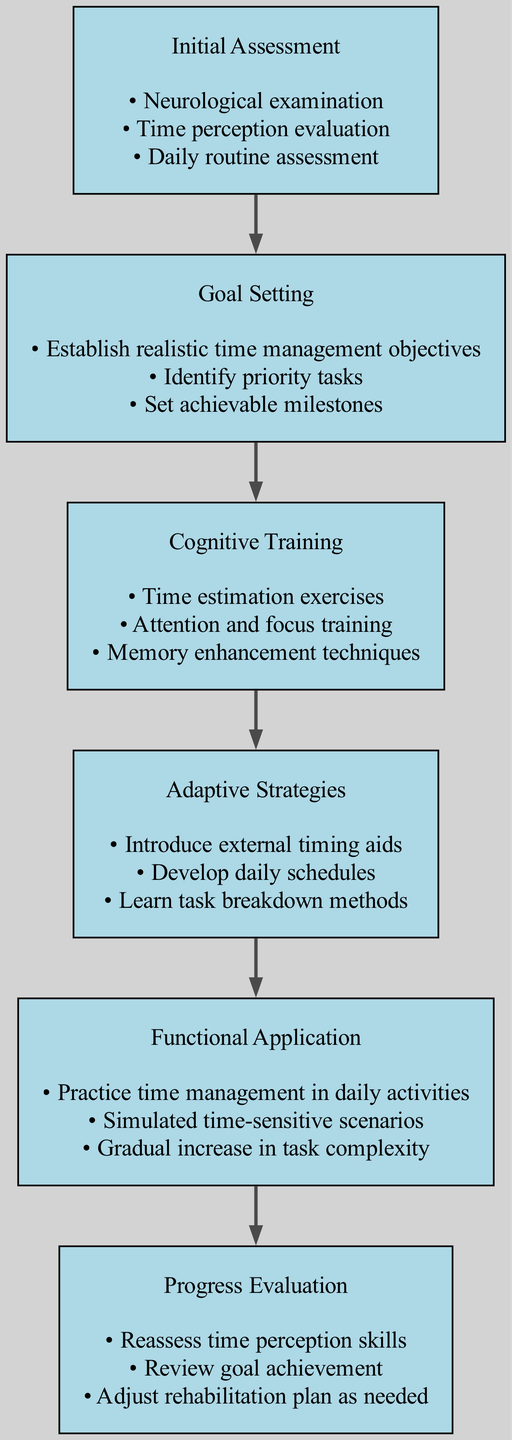What is the first stage of the rehabilitation program? The diagram clearly indicates the first stage at the top, labeled "Initial Assessment".
Answer: Initial Assessment How many activities are listed under the "Goal Setting" stage? By counting the bullet points under the "Goal Setting" node, we see there are three activities listed.
Answer: 3 What is the last stage of the rehabilitation program? The last stage is found at the bottom of the diagram, labeled "Progress Evaluation".
Answer: Progress Evaluation Which stage includes "Time estimation exercises"? This activity is specifically listed under the "Cognitive Training" stage, as indicated in the diagram.
Answer: Cognitive Training What connects "Functional Application" and "Progress Evaluation"? There is a directed edge connecting these two stages that indicates the sequential flow from "Functional Application" to "Progress Evaluation".
Answer: Progress Evaluation Which stage comes before "Adaptive Strategies"? The diagram shows that the "Cognitive Training" stage is followed by "Adaptive Strategies", making it the preceding stage.
Answer: Cognitive Training How many total stages are represented in the diagram? By counting each unique stage in the diagram, we find there are six distinct stages.
Answer: 6 What is one activity mentioned in the "Initial Assessment"? The node for "Initial Assessment" lists multiple activities, one of which is "Neurological examination".
Answer: Neurological examination Which stage has "Introduce external timing aids" as an activity? The activity "Introduce external timing aids" is included under the "Adaptive Strategies" stage, as shown in the diagram.
Answer: Adaptive Strategies 